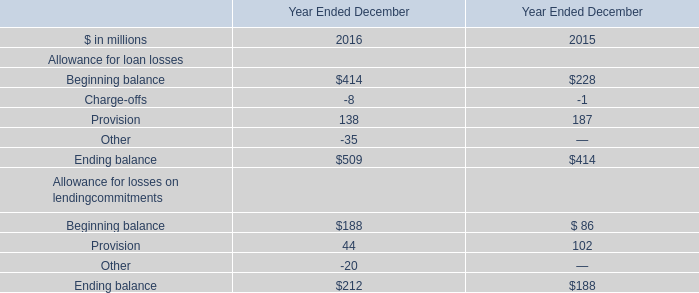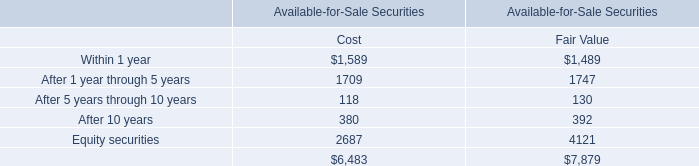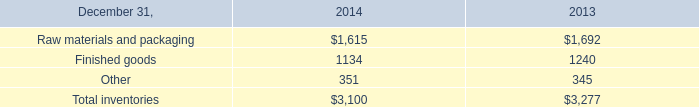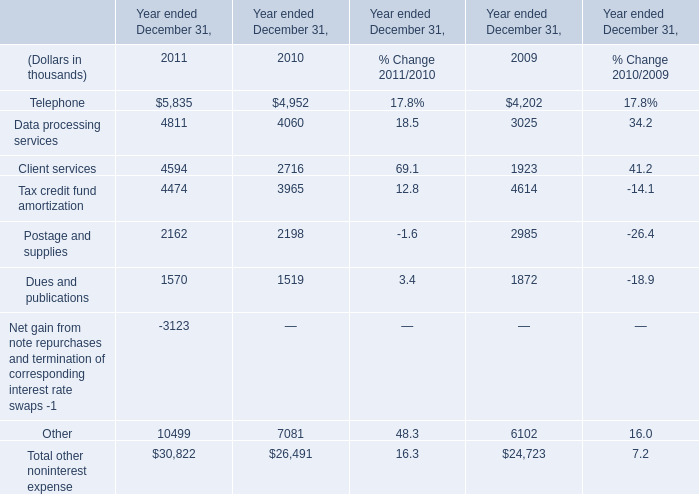In what year is Client services greater than 4000? 
Answer: 2011. 